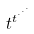Convert formula to latex. <formula><loc_0><loc_0><loc_500><loc_500>t ^ { t ^ { \cdot ^ { \cdot ^ { \cdot } } } }</formula> 